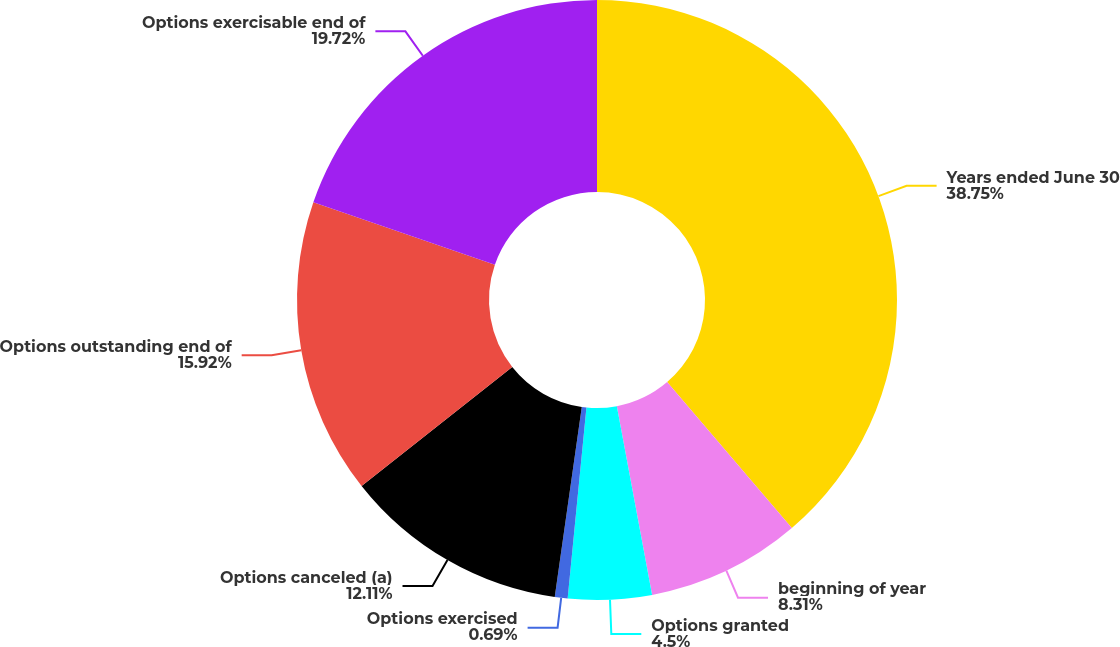<chart> <loc_0><loc_0><loc_500><loc_500><pie_chart><fcel>Years ended June 30<fcel>beginning of year<fcel>Options granted<fcel>Options exercised<fcel>Options canceled (a)<fcel>Options outstanding end of<fcel>Options exercisable end of<nl><fcel>38.75%<fcel>8.31%<fcel>4.5%<fcel>0.69%<fcel>12.11%<fcel>15.92%<fcel>19.72%<nl></chart> 